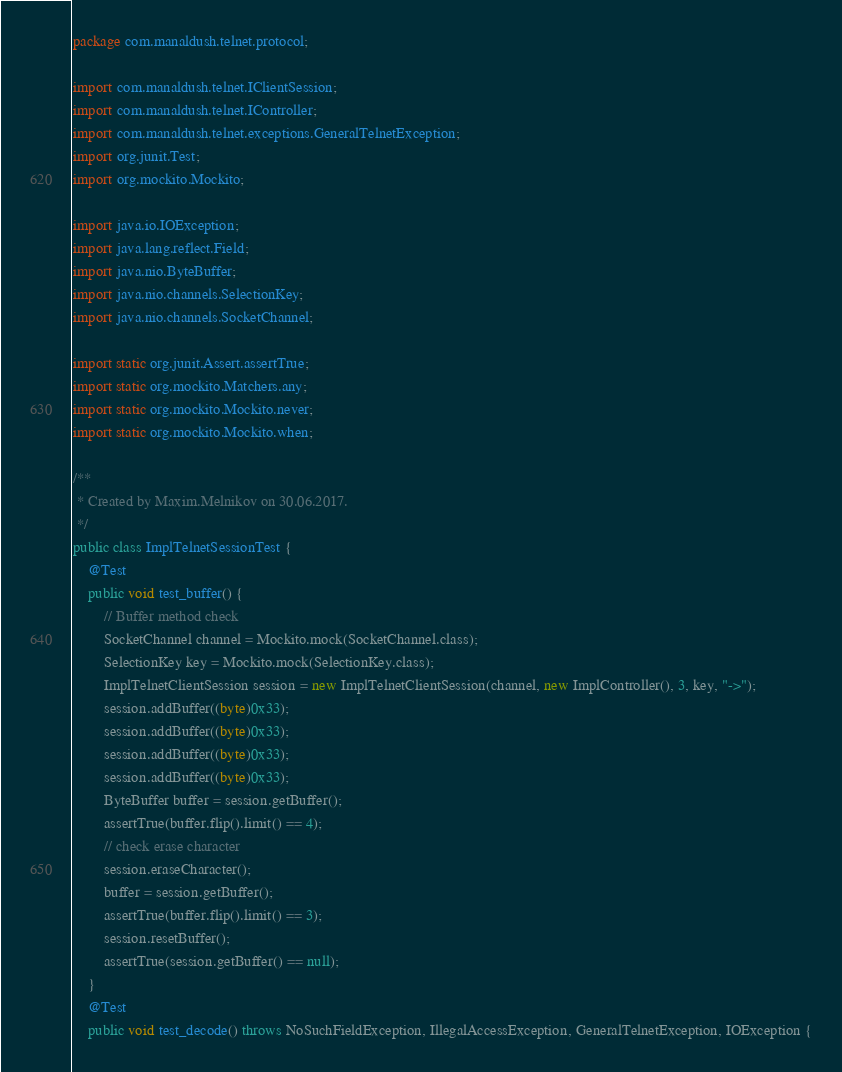<code> <loc_0><loc_0><loc_500><loc_500><_Java_>package com.manaldush.telnet.protocol;

import com.manaldush.telnet.IClientSession;
import com.manaldush.telnet.IController;
import com.manaldush.telnet.exceptions.GeneralTelnetException;
import org.junit.Test;
import org.mockito.Mockito;

import java.io.IOException;
import java.lang.reflect.Field;
import java.nio.ByteBuffer;
import java.nio.channels.SelectionKey;
import java.nio.channels.SocketChannel;

import static org.junit.Assert.assertTrue;
import static org.mockito.Matchers.any;
import static org.mockito.Mockito.never;
import static org.mockito.Mockito.when;

/**
 * Created by Maxim.Melnikov on 30.06.2017.
 */
public class ImplTelnetSessionTest {
    @Test
    public void test_buffer() {
        // Buffer method check
        SocketChannel channel = Mockito.mock(SocketChannel.class);
        SelectionKey key = Mockito.mock(SelectionKey.class);
        ImplTelnetClientSession session = new ImplTelnetClientSession(channel, new ImplController(), 3, key, "->");
        session.addBuffer((byte)0x33);
        session.addBuffer((byte)0x33);
        session.addBuffer((byte)0x33);
        session.addBuffer((byte)0x33);
        ByteBuffer buffer = session.getBuffer();
        assertTrue(buffer.flip().limit() == 4);
        // check erase character
        session.eraseCharacter();
        buffer = session.getBuffer();
        assertTrue(buffer.flip().limit() == 3);
        session.resetBuffer();
        assertTrue(session.getBuffer() == null);
    }
    @Test
    public void test_decode() throws NoSuchFieldException, IllegalAccessException, GeneralTelnetException, IOException {</code> 